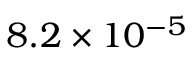<formula> <loc_0><loc_0><loc_500><loc_500>8 . 2 \times 1 0 ^ { - 5 }</formula> 